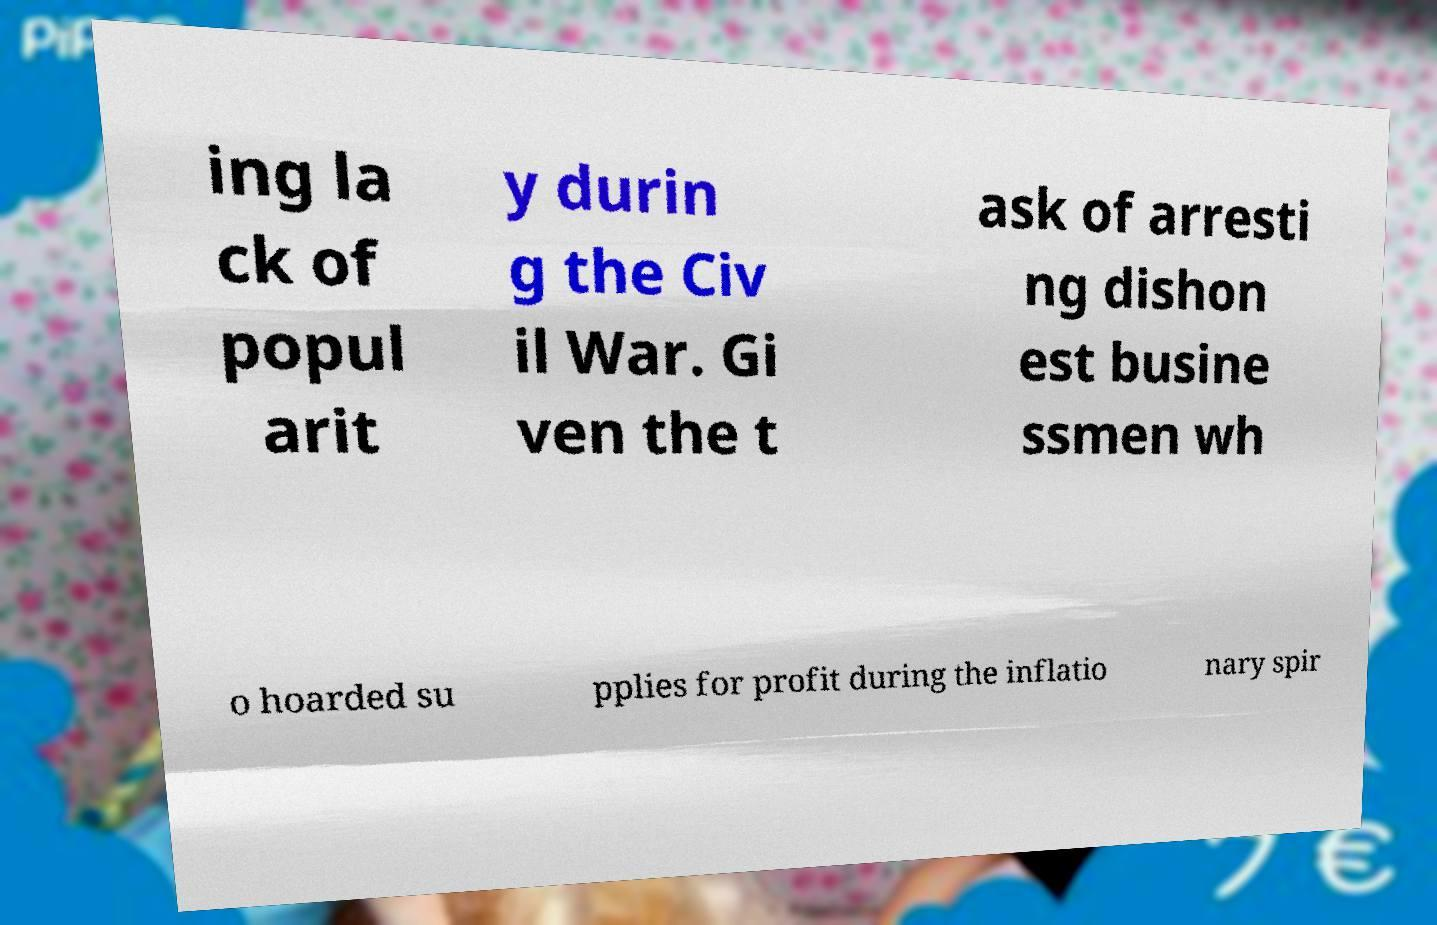What messages or text are displayed in this image? I need them in a readable, typed format. ing la ck of popul arit y durin g the Civ il War. Gi ven the t ask of arresti ng dishon est busine ssmen wh o hoarded su pplies for profit during the inflatio nary spir 